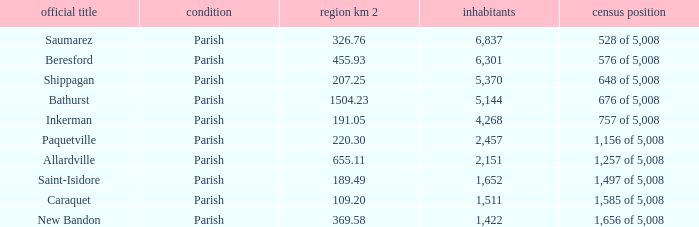What is the Population of the New Bandon Parish with an Area km 2 larger than 326.76? 1422.0. 